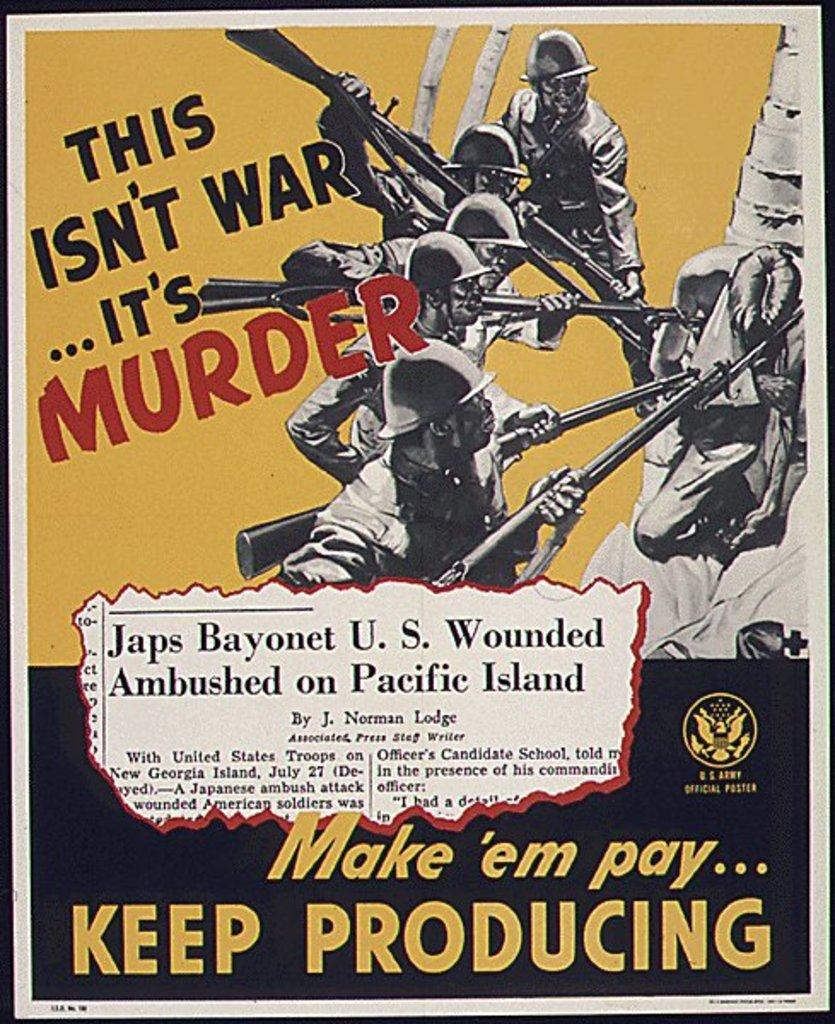Provide a one-sentence caption for the provided image. U.S. Army Official Poster of 5 Japanese soldiers bayoneting a U.S. wounded soldier. 